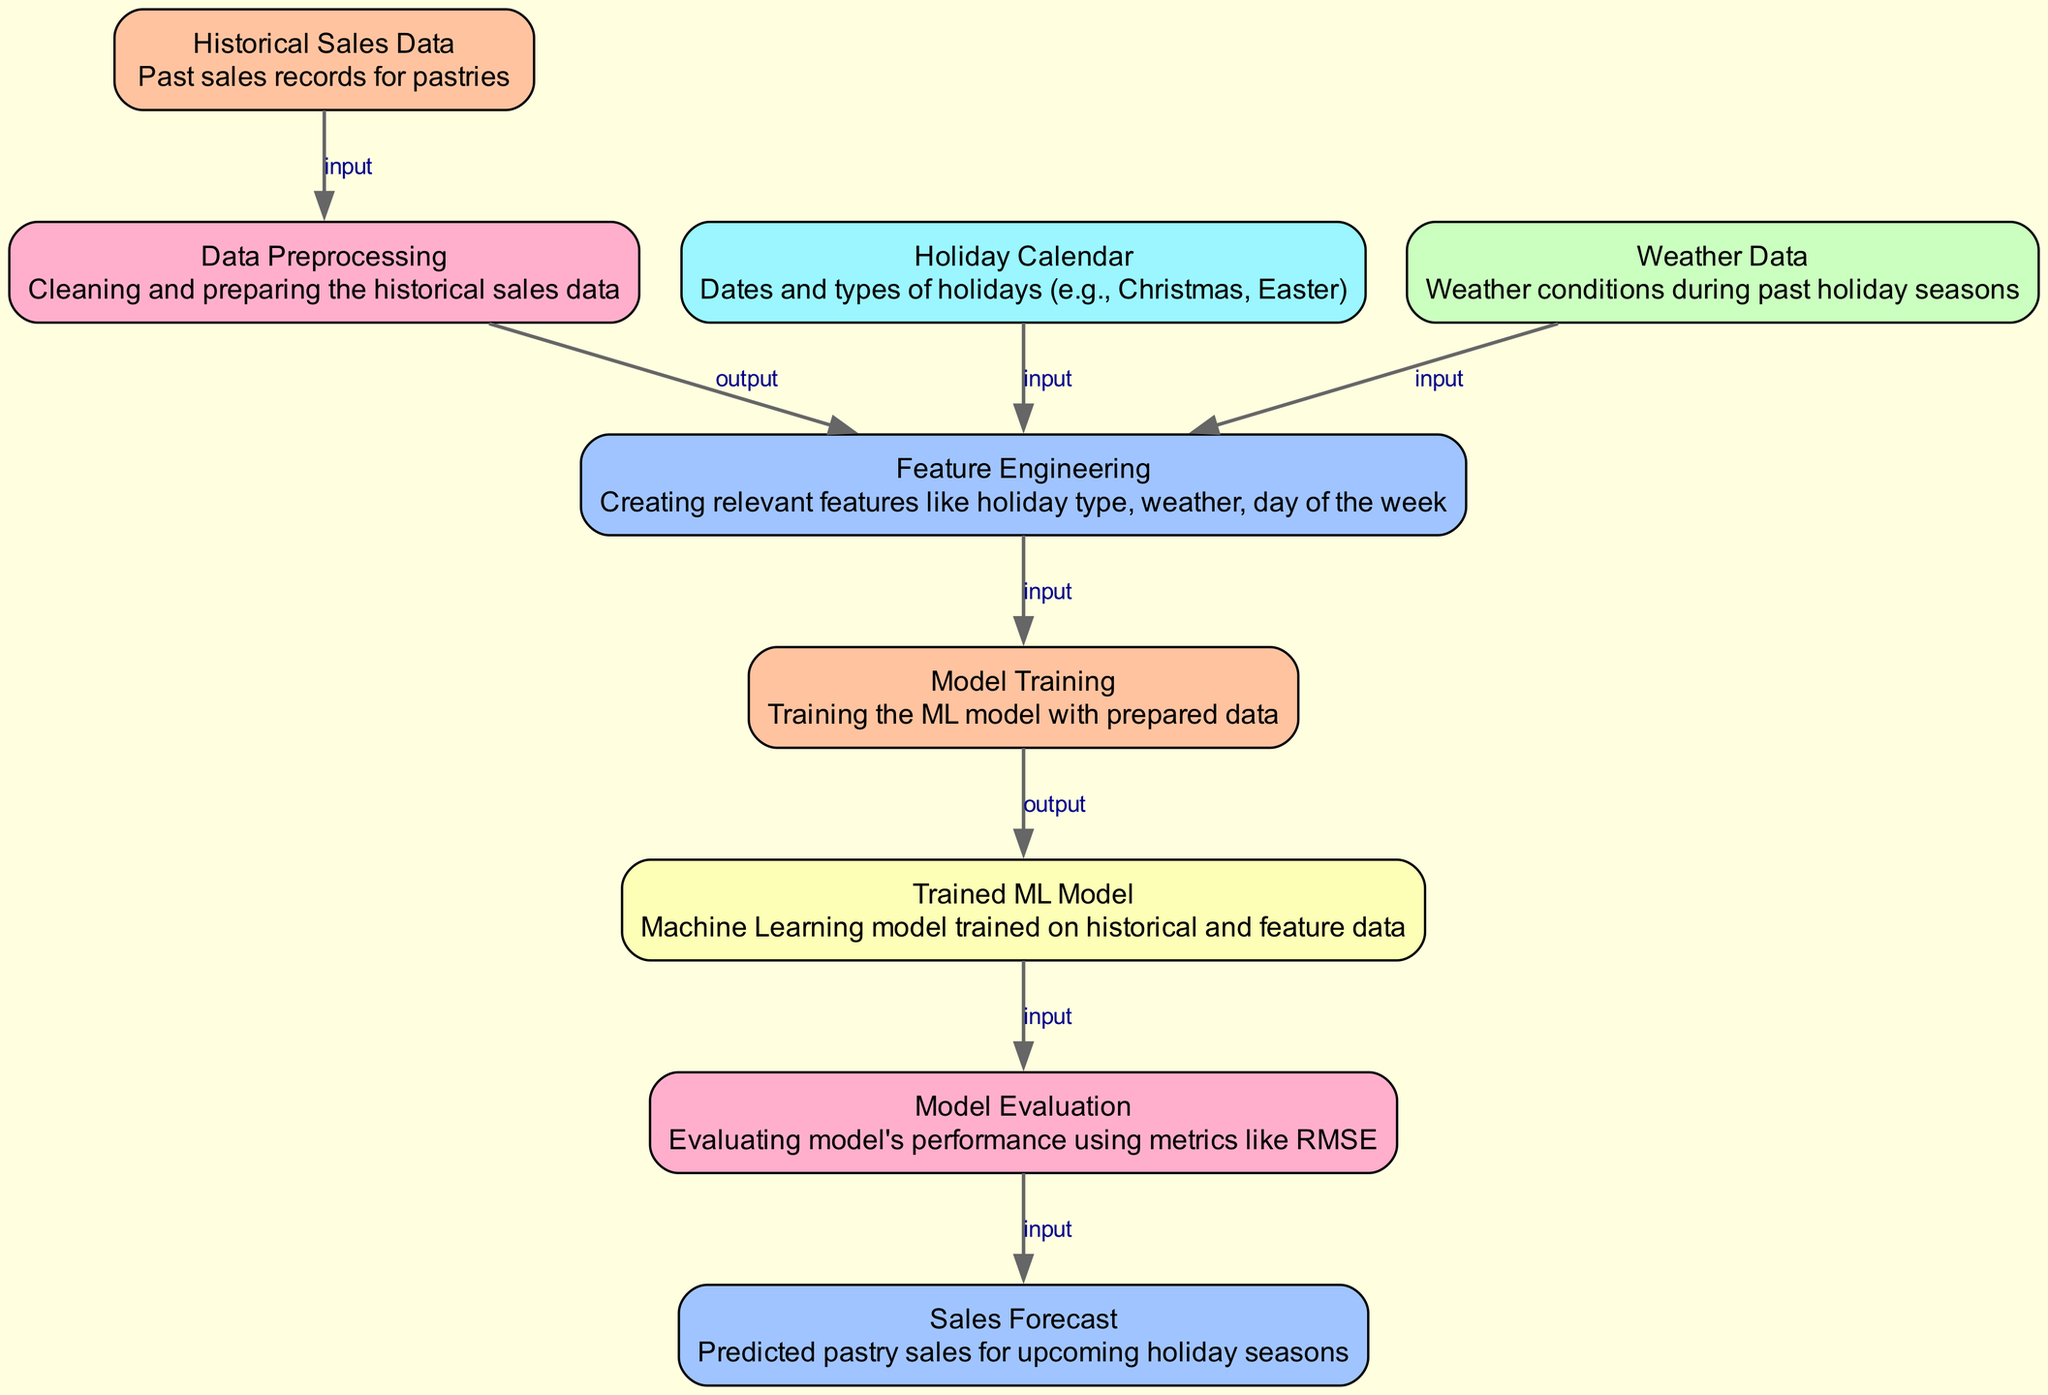What is the input for data preprocessing? The input for data preprocessing comes from the historical sales data node. This is indicated by the edge labeled "input" connecting the historical data node to the data preprocessing node.
Answer: Historical Sales Data How many nodes are present in the diagram? By counting the nodes listed in the `nodes` section of the diagram data, we find that there are a total of nine nodes involved in the sales forecasting process.
Answer: 9 Which node generates the sales forecast? The sales forecast output is generated from the model evaluation node, as indicated by the arrow labeled "input" that leads from the model evaluation node to the sales forecast node.
Answer: Model Evaluation What type of features are created during feature engineering? Features created during feature engineering include holiday type, weather, and day of the week, as stated in the description of the feature engineering node.
Answer: Holiday type, weather, day of the week What is the link between model training and the trained ML model? The link between model training and the trained ML model is an output from the model training node to the ml model node, denoting that model training produces a trained machine learning model.
Answer: Output In which step is weather data used? Weather data is used during the feature engineering step, as shown by the input link from weather data to the feature engineering node, indicating that it is one of the sources for feature creation.
Answer: Feature Engineering What performance metric is mentioned for model evaluation? The performance metric mentioned during model evaluation is RMSE, which is a common metric for assessing the accuracy of regression models and is referenced in the description of the model evaluation node.
Answer: RMSE Which nodes feed into the feature engineering step? The nodes feeding into feature engineering are the historical sales data, holiday calendar, and weather data. Each of these nodes contributes information necessary for creating relevant features.
Answer: Historical sales data, holiday calendar, weather data What is the output of the model evaluation step? The output of the model evaluation step is the sales forecast, as indicated by the connecting edge labeled "input" leading to the sales forecast node from the model evaluation node.
Answer: Sales Forecast 